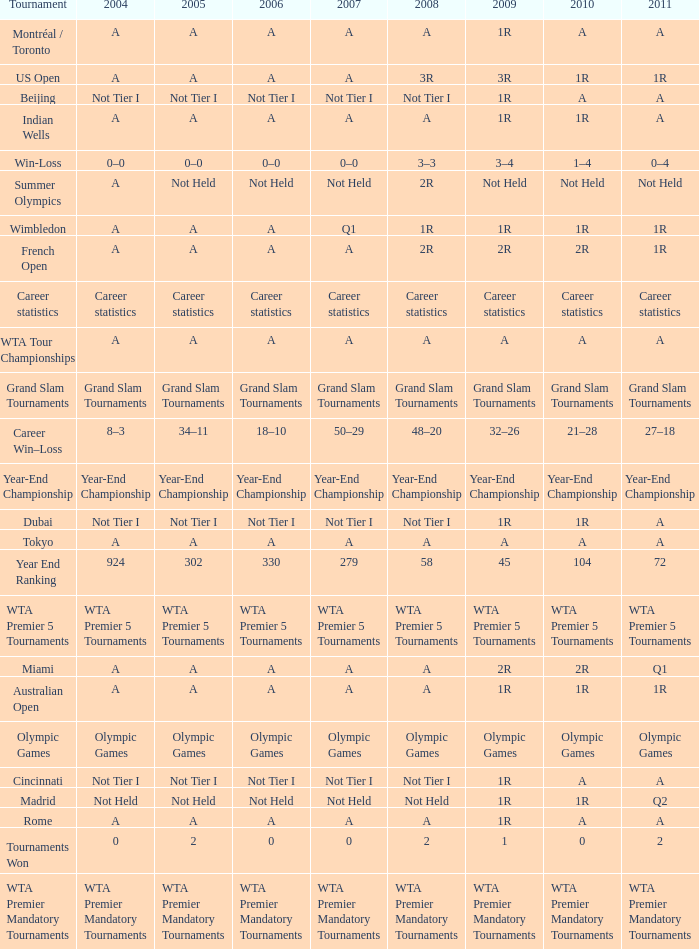What is 2004, when 2008 is "WTA Premier 5 Tournaments"? WTA Premier 5 Tournaments. 